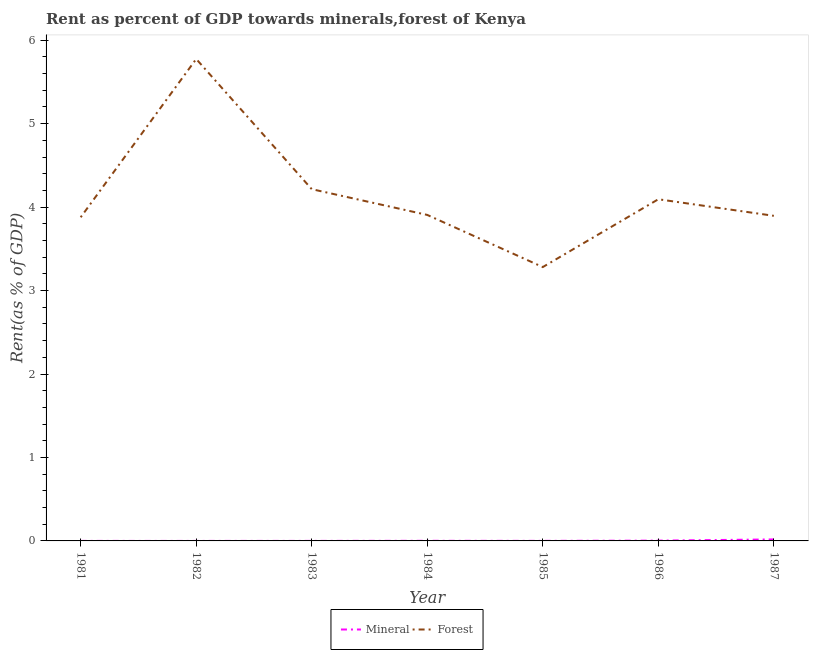How many different coloured lines are there?
Offer a very short reply. 2. What is the forest rent in 1987?
Your response must be concise. 3.9. Across all years, what is the maximum forest rent?
Your answer should be compact. 5.77. Across all years, what is the minimum forest rent?
Offer a terse response. 3.28. What is the total forest rent in the graph?
Provide a short and direct response. 29.04. What is the difference between the mineral rent in 1982 and that in 1986?
Your response must be concise. -0. What is the difference between the forest rent in 1981 and the mineral rent in 1983?
Your answer should be very brief. 3.88. What is the average mineral rent per year?
Ensure brevity in your answer.  0. In the year 1985, what is the difference between the mineral rent and forest rent?
Your answer should be compact. -3.28. In how many years, is the mineral rent greater than 1.8 %?
Keep it short and to the point. 0. What is the ratio of the forest rent in 1983 to that in 1986?
Offer a terse response. 1.03. What is the difference between the highest and the second highest forest rent?
Your response must be concise. 1.56. What is the difference between the highest and the lowest forest rent?
Give a very brief answer. 2.49. In how many years, is the mineral rent greater than the average mineral rent taken over all years?
Your answer should be very brief. 2. Is the sum of the forest rent in 1982 and 1985 greater than the maximum mineral rent across all years?
Your answer should be compact. Yes. Does the forest rent monotonically increase over the years?
Your answer should be very brief. No. Is the forest rent strictly greater than the mineral rent over the years?
Offer a terse response. Yes. Is the mineral rent strictly less than the forest rent over the years?
Your answer should be very brief. Yes. How many years are there in the graph?
Provide a succinct answer. 7. Are the values on the major ticks of Y-axis written in scientific E-notation?
Provide a succinct answer. No. Does the graph contain any zero values?
Keep it short and to the point. No. Does the graph contain grids?
Provide a short and direct response. No. Where does the legend appear in the graph?
Offer a very short reply. Bottom center. How many legend labels are there?
Your answer should be compact. 2. How are the legend labels stacked?
Provide a short and direct response. Horizontal. What is the title of the graph?
Your answer should be very brief. Rent as percent of GDP towards minerals,forest of Kenya. What is the label or title of the X-axis?
Offer a terse response. Year. What is the label or title of the Y-axis?
Give a very brief answer. Rent(as % of GDP). What is the Rent(as % of GDP) in Mineral in 1981?
Keep it short and to the point. 9.89683064769055e-5. What is the Rent(as % of GDP) in Forest in 1981?
Keep it short and to the point. 3.88. What is the Rent(as % of GDP) of Mineral in 1982?
Give a very brief answer. 6.72101396452568e-5. What is the Rent(as % of GDP) of Forest in 1982?
Provide a short and direct response. 5.77. What is the Rent(as % of GDP) of Mineral in 1983?
Keep it short and to the point. 0. What is the Rent(as % of GDP) of Forest in 1983?
Ensure brevity in your answer.  4.21. What is the Rent(as % of GDP) of Mineral in 1984?
Your answer should be compact. 0. What is the Rent(as % of GDP) in Forest in 1984?
Keep it short and to the point. 3.91. What is the Rent(as % of GDP) of Mineral in 1985?
Make the answer very short. 0. What is the Rent(as % of GDP) of Forest in 1985?
Offer a very short reply. 3.28. What is the Rent(as % of GDP) of Mineral in 1986?
Offer a very short reply. 0. What is the Rent(as % of GDP) of Forest in 1986?
Provide a short and direct response. 4.09. What is the Rent(as % of GDP) in Mineral in 1987?
Ensure brevity in your answer.  0.02. What is the Rent(as % of GDP) of Forest in 1987?
Provide a succinct answer. 3.9. Across all years, what is the maximum Rent(as % of GDP) of Mineral?
Your response must be concise. 0.02. Across all years, what is the maximum Rent(as % of GDP) of Forest?
Offer a terse response. 5.77. Across all years, what is the minimum Rent(as % of GDP) in Mineral?
Ensure brevity in your answer.  6.72101396452568e-5. Across all years, what is the minimum Rent(as % of GDP) of Forest?
Make the answer very short. 3.28. What is the total Rent(as % of GDP) in Mineral in the graph?
Give a very brief answer. 0.02. What is the total Rent(as % of GDP) of Forest in the graph?
Make the answer very short. 29.04. What is the difference between the Rent(as % of GDP) in Forest in 1981 and that in 1982?
Your response must be concise. -1.9. What is the difference between the Rent(as % of GDP) in Mineral in 1981 and that in 1983?
Give a very brief answer. -0. What is the difference between the Rent(as % of GDP) in Forest in 1981 and that in 1983?
Keep it short and to the point. -0.34. What is the difference between the Rent(as % of GDP) in Mineral in 1981 and that in 1984?
Your answer should be very brief. -0. What is the difference between the Rent(as % of GDP) in Forest in 1981 and that in 1984?
Offer a terse response. -0.03. What is the difference between the Rent(as % of GDP) in Mineral in 1981 and that in 1985?
Your answer should be very brief. -0. What is the difference between the Rent(as % of GDP) in Forest in 1981 and that in 1985?
Your response must be concise. 0.6. What is the difference between the Rent(as % of GDP) of Mineral in 1981 and that in 1986?
Give a very brief answer. -0. What is the difference between the Rent(as % of GDP) of Forest in 1981 and that in 1986?
Keep it short and to the point. -0.22. What is the difference between the Rent(as % of GDP) of Mineral in 1981 and that in 1987?
Make the answer very short. -0.02. What is the difference between the Rent(as % of GDP) in Forest in 1981 and that in 1987?
Ensure brevity in your answer.  -0.02. What is the difference between the Rent(as % of GDP) of Mineral in 1982 and that in 1983?
Offer a terse response. -0. What is the difference between the Rent(as % of GDP) in Forest in 1982 and that in 1983?
Your response must be concise. 1.56. What is the difference between the Rent(as % of GDP) in Mineral in 1982 and that in 1984?
Make the answer very short. -0. What is the difference between the Rent(as % of GDP) of Forest in 1982 and that in 1984?
Give a very brief answer. 1.87. What is the difference between the Rent(as % of GDP) in Mineral in 1982 and that in 1985?
Keep it short and to the point. -0. What is the difference between the Rent(as % of GDP) of Forest in 1982 and that in 1985?
Your answer should be very brief. 2.49. What is the difference between the Rent(as % of GDP) in Mineral in 1982 and that in 1986?
Your response must be concise. -0. What is the difference between the Rent(as % of GDP) in Forest in 1982 and that in 1986?
Give a very brief answer. 1.68. What is the difference between the Rent(as % of GDP) of Mineral in 1982 and that in 1987?
Offer a very short reply. -0.02. What is the difference between the Rent(as % of GDP) in Forest in 1982 and that in 1987?
Offer a very short reply. 1.88. What is the difference between the Rent(as % of GDP) of Mineral in 1983 and that in 1984?
Keep it short and to the point. -0. What is the difference between the Rent(as % of GDP) in Forest in 1983 and that in 1984?
Your answer should be very brief. 0.31. What is the difference between the Rent(as % of GDP) in Mineral in 1983 and that in 1985?
Make the answer very short. -0. What is the difference between the Rent(as % of GDP) of Forest in 1983 and that in 1985?
Offer a very short reply. 0.93. What is the difference between the Rent(as % of GDP) of Mineral in 1983 and that in 1986?
Give a very brief answer. -0. What is the difference between the Rent(as % of GDP) in Forest in 1983 and that in 1986?
Provide a succinct answer. 0.12. What is the difference between the Rent(as % of GDP) of Mineral in 1983 and that in 1987?
Keep it short and to the point. -0.02. What is the difference between the Rent(as % of GDP) of Forest in 1983 and that in 1987?
Provide a succinct answer. 0.32. What is the difference between the Rent(as % of GDP) in Mineral in 1984 and that in 1985?
Give a very brief answer. 0. What is the difference between the Rent(as % of GDP) of Forest in 1984 and that in 1985?
Keep it short and to the point. 0.62. What is the difference between the Rent(as % of GDP) in Mineral in 1984 and that in 1986?
Your answer should be compact. -0. What is the difference between the Rent(as % of GDP) of Forest in 1984 and that in 1986?
Keep it short and to the point. -0.19. What is the difference between the Rent(as % of GDP) of Mineral in 1984 and that in 1987?
Give a very brief answer. -0.02. What is the difference between the Rent(as % of GDP) of Forest in 1984 and that in 1987?
Your answer should be very brief. 0.01. What is the difference between the Rent(as % of GDP) in Mineral in 1985 and that in 1986?
Offer a very short reply. -0. What is the difference between the Rent(as % of GDP) in Forest in 1985 and that in 1986?
Provide a succinct answer. -0.81. What is the difference between the Rent(as % of GDP) in Mineral in 1985 and that in 1987?
Your answer should be very brief. -0.02. What is the difference between the Rent(as % of GDP) in Forest in 1985 and that in 1987?
Your response must be concise. -0.61. What is the difference between the Rent(as % of GDP) in Mineral in 1986 and that in 1987?
Offer a terse response. -0.01. What is the difference between the Rent(as % of GDP) in Forest in 1986 and that in 1987?
Your response must be concise. 0.2. What is the difference between the Rent(as % of GDP) of Mineral in 1981 and the Rent(as % of GDP) of Forest in 1982?
Make the answer very short. -5.77. What is the difference between the Rent(as % of GDP) of Mineral in 1981 and the Rent(as % of GDP) of Forest in 1983?
Your answer should be very brief. -4.21. What is the difference between the Rent(as % of GDP) of Mineral in 1981 and the Rent(as % of GDP) of Forest in 1984?
Provide a short and direct response. -3.91. What is the difference between the Rent(as % of GDP) of Mineral in 1981 and the Rent(as % of GDP) of Forest in 1985?
Make the answer very short. -3.28. What is the difference between the Rent(as % of GDP) of Mineral in 1981 and the Rent(as % of GDP) of Forest in 1986?
Keep it short and to the point. -4.09. What is the difference between the Rent(as % of GDP) in Mineral in 1981 and the Rent(as % of GDP) in Forest in 1987?
Your answer should be compact. -3.9. What is the difference between the Rent(as % of GDP) in Mineral in 1982 and the Rent(as % of GDP) in Forest in 1983?
Your answer should be very brief. -4.21. What is the difference between the Rent(as % of GDP) in Mineral in 1982 and the Rent(as % of GDP) in Forest in 1984?
Make the answer very short. -3.91. What is the difference between the Rent(as % of GDP) in Mineral in 1982 and the Rent(as % of GDP) in Forest in 1985?
Make the answer very short. -3.28. What is the difference between the Rent(as % of GDP) in Mineral in 1982 and the Rent(as % of GDP) in Forest in 1986?
Offer a very short reply. -4.09. What is the difference between the Rent(as % of GDP) of Mineral in 1982 and the Rent(as % of GDP) of Forest in 1987?
Keep it short and to the point. -3.9. What is the difference between the Rent(as % of GDP) in Mineral in 1983 and the Rent(as % of GDP) in Forest in 1984?
Provide a succinct answer. -3.91. What is the difference between the Rent(as % of GDP) of Mineral in 1983 and the Rent(as % of GDP) of Forest in 1985?
Give a very brief answer. -3.28. What is the difference between the Rent(as % of GDP) in Mineral in 1983 and the Rent(as % of GDP) in Forest in 1986?
Make the answer very short. -4.09. What is the difference between the Rent(as % of GDP) in Mineral in 1983 and the Rent(as % of GDP) in Forest in 1987?
Give a very brief answer. -3.9. What is the difference between the Rent(as % of GDP) in Mineral in 1984 and the Rent(as % of GDP) in Forest in 1985?
Keep it short and to the point. -3.28. What is the difference between the Rent(as % of GDP) in Mineral in 1984 and the Rent(as % of GDP) in Forest in 1986?
Offer a terse response. -4.09. What is the difference between the Rent(as % of GDP) in Mineral in 1984 and the Rent(as % of GDP) in Forest in 1987?
Offer a very short reply. -3.89. What is the difference between the Rent(as % of GDP) of Mineral in 1985 and the Rent(as % of GDP) of Forest in 1986?
Your answer should be compact. -4.09. What is the difference between the Rent(as % of GDP) of Mineral in 1985 and the Rent(as % of GDP) of Forest in 1987?
Offer a very short reply. -3.89. What is the difference between the Rent(as % of GDP) of Mineral in 1986 and the Rent(as % of GDP) of Forest in 1987?
Offer a terse response. -3.89. What is the average Rent(as % of GDP) in Mineral per year?
Ensure brevity in your answer.  0. What is the average Rent(as % of GDP) in Forest per year?
Ensure brevity in your answer.  4.15. In the year 1981, what is the difference between the Rent(as % of GDP) of Mineral and Rent(as % of GDP) of Forest?
Keep it short and to the point. -3.88. In the year 1982, what is the difference between the Rent(as % of GDP) of Mineral and Rent(as % of GDP) of Forest?
Your answer should be compact. -5.77. In the year 1983, what is the difference between the Rent(as % of GDP) of Mineral and Rent(as % of GDP) of Forest?
Your answer should be compact. -4.21. In the year 1984, what is the difference between the Rent(as % of GDP) of Mineral and Rent(as % of GDP) of Forest?
Your answer should be compact. -3.9. In the year 1985, what is the difference between the Rent(as % of GDP) of Mineral and Rent(as % of GDP) of Forest?
Ensure brevity in your answer.  -3.28. In the year 1986, what is the difference between the Rent(as % of GDP) in Mineral and Rent(as % of GDP) in Forest?
Offer a terse response. -4.09. In the year 1987, what is the difference between the Rent(as % of GDP) in Mineral and Rent(as % of GDP) in Forest?
Offer a terse response. -3.88. What is the ratio of the Rent(as % of GDP) in Mineral in 1981 to that in 1982?
Ensure brevity in your answer.  1.47. What is the ratio of the Rent(as % of GDP) in Forest in 1981 to that in 1982?
Provide a short and direct response. 0.67. What is the ratio of the Rent(as % of GDP) in Mineral in 1981 to that in 1983?
Your answer should be very brief. 0.33. What is the ratio of the Rent(as % of GDP) of Forest in 1981 to that in 1983?
Make the answer very short. 0.92. What is the ratio of the Rent(as % of GDP) in Mineral in 1981 to that in 1984?
Keep it short and to the point. 0.08. What is the ratio of the Rent(as % of GDP) in Forest in 1981 to that in 1984?
Your answer should be compact. 0.99. What is the ratio of the Rent(as % of GDP) of Mineral in 1981 to that in 1985?
Provide a short and direct response. 0.15. What is the ratio of the Rent(as % of GDP) in Forest in 1981 to that in 1985?
Ensure brevity in your answer.  1.18. What is the ratio of the Rent(as % of GDP) of Mineral in 1981 to that in 1986?
Provide a succinct answer. 0.03. What is the ratio of the Rent(as % of GDP) of Forest in 1981 to that in 1986?
Provide a succinct answer. 0.95. What is the ratio of the Rent(as % of GDP) in Mineral in 1981 to that in 1987?
Offer a very short reply. 0.01. What is the ratio of the Rent(as % of GDP) of Mineral in 1982 to that in 1983?
Your answer should be very brief. 0.22. What is the ratio of the Rent(as % of GDP) of Forest in 1982 to that in 1983?
Your response must be concise. 1.37. What is the ratio of the Rent(as % of GDP) of Mineral in 1982 to that in 1984?
Offer a terse response. 0.05. What is the ratio of the Rent(as % of GDP) of Forest in 1982 to that in 1984?
Keep it short and to the point. 1.48. What is the ratio of the Rent(as % of GDP) in Mineral in 1982 to that in 1985?
Your response must be concise. 0.1. What is the ratio of the Rent(as % of GDP) in Forest in 1982 to that in 1985?
Ensure brevity in your answer.  1.76. What is the ratio of the Rent(as % of GDP) in Mineral in 1982 to that in 1986?
Provide a succinct answer. 0.02. What is the ratio of the Rent(as % of GDP) of Forest in 1982 to that in 1986?
Keep it short and to the point. 1.41. What is the ratio of the Rent(as % of GDP) in Mineral in 1982 to that in 1987?
Your answer should be very brief. 0. What is the ratio of the Rent(as % of GDP) in Forest in 1982 to that in 1987?
Offer a terse response. 1.48. What is the ratio of the Rent(as % of GDP) in Mineral in 1983 to that in 1984?
Provide a succinct answer. 0.23. What is the ratio of the Rent(as % of GDP) of Forest in 1983 to that in 1984?
Provide a succinct answer. 1.08. What is the ratio of the Rent(as % of GDP) in Mineral in 1983 to that in 1985?
Provide a short and direct response. 0.46. What is the ratio of the Rent(as % of GDP) of Forest in 1983 to that in 1985?
Make the answer very short. 1.28. What is the ratio of the Rent(as % of GDP) of Mineral in 1983 to that in 1986?
Your answer should be very brief. 0.09. What is the ratio of the Rent(as % of GDP) in Forest in 1983 to that in 1986?
Offer a very short reply. 1.03. What is the ratio of the Rent(as % of GDP) of Mineral in 1983 to that in 1987?
Offer a terse response. 0.02. What is the ratio of the Rent(as % of GDP) of Forest in 1983 to that in 1987?
Ensure brevity in your answer.  1.08. What is the ratio of the Rent(as % of GDP) in Mineral in 1984 to that in 1985?
Provide a short and direct response. 1.94. What is the ratio of the Rent(as % of GDP) of Forest in 1984 to that in 1985?
Offer a terse response. 1.19. What is the ratio of the Rent(as % of GDP) of Mineral in 1984 to that in 1986?
Offer a terse response. 0.37. What is the ratio of the Rent(as % of GDP) of Forest in 1984 to that in 1986?
Keep it short and to the point. 0.95. What is the ratio of the Rent(as % of GDP) in Mineral in 1984 to that in 1987?
Give a very brief answer. 0.07. What is the ratio of the Rent(as % of GDP) of Mineral in 1985 to that in 1986?
Provide a short and direct response. 0.19. What is the ratio of the Rent(as % of GDP) in Forest in 1985 to that in 1986?
Ensure brevity in your answer.  0.8. What is the ratio of the Rent(as % of GDP) in Mineral in 1985 to that in 1987?
Ensure brevity in your answer.  0.04. What is the ratio of the Rent(as % of GDP) in Forest in 1985 to that in 1987?
Keep it short and to the point. 0.84. What is the ratio of the Rent(as % of GDP) of Mineral in 1986 to that in 1987?
Your answer should be very brief. 0.19. What is the ratio of the Rent(as % of GDP) in Forest in 1986 to that in 1987?
Offer a terse response. 1.05. What is the difference between the highest and the second highest Rent(as % of GDP) of Mineral?
Offer a terse response. 0.01. What is the difference between the highest and the second highest Rent(as % of GDP) of Forest?
Give a very brief answer. 1.56. What is the difference between the highest and the lowest Rent(as % of GDP) of Mineral?
Provide a short and direct response. 0.02. What is the difference between the highest and the lowest Rent(as % of GDP) of Forest?
Your answer should be very brief. 2.49. 